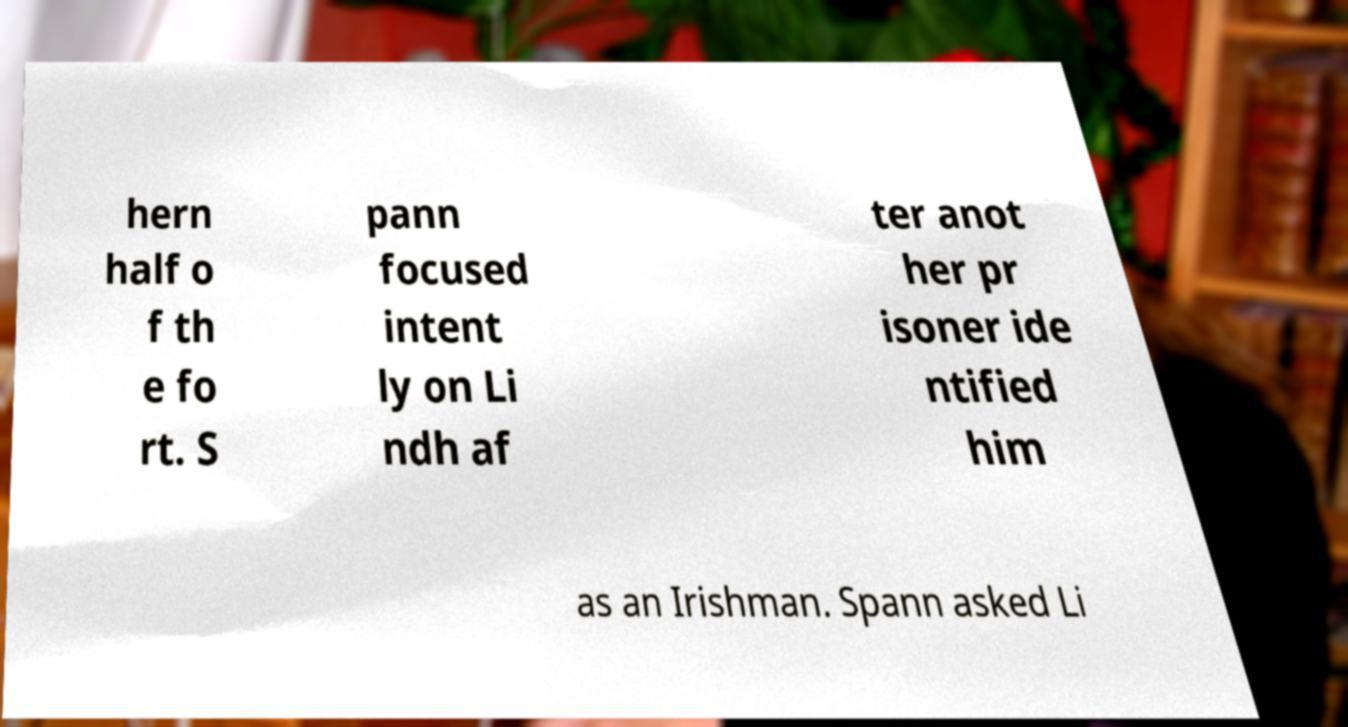Could you assist in decoding the text presented in this image and type it out clearly? hern half o f th e fo rt. S pann focused intent ly on Li ndh af ter anot her pr isoner ide ntified him as an Irishman. Spann asked Li 